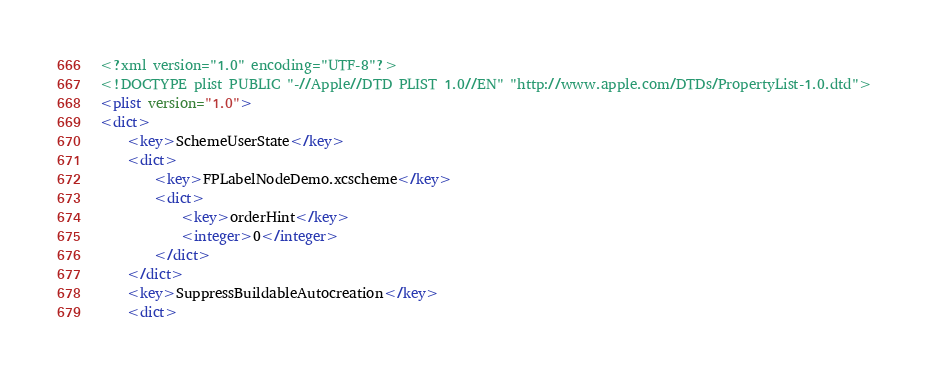Convert code to text. <code><loc_0><loc_0><loc_500><loc_500><_XML_><?xml version="1.0" encoding="UTF-8"?>
<!DOCTYPE plist PUBLIC "-//Apple//DTD PLIST 1.0//EN" "http://www.apple.com/DTDs/PropertyList-1.0.dtd">
<plist version="1.0">
<dict>
	<key>SchemeUserState</key>
	<dict>
		<key>FPLabelNodeDemo.xcscheme</key>
		<dict>
			<key>orderHint</key>
			<integer>0</integer>
		</dict>
	</dict>
	<key>SuppressBuildableAutocreation</key>
	<dict></code> 